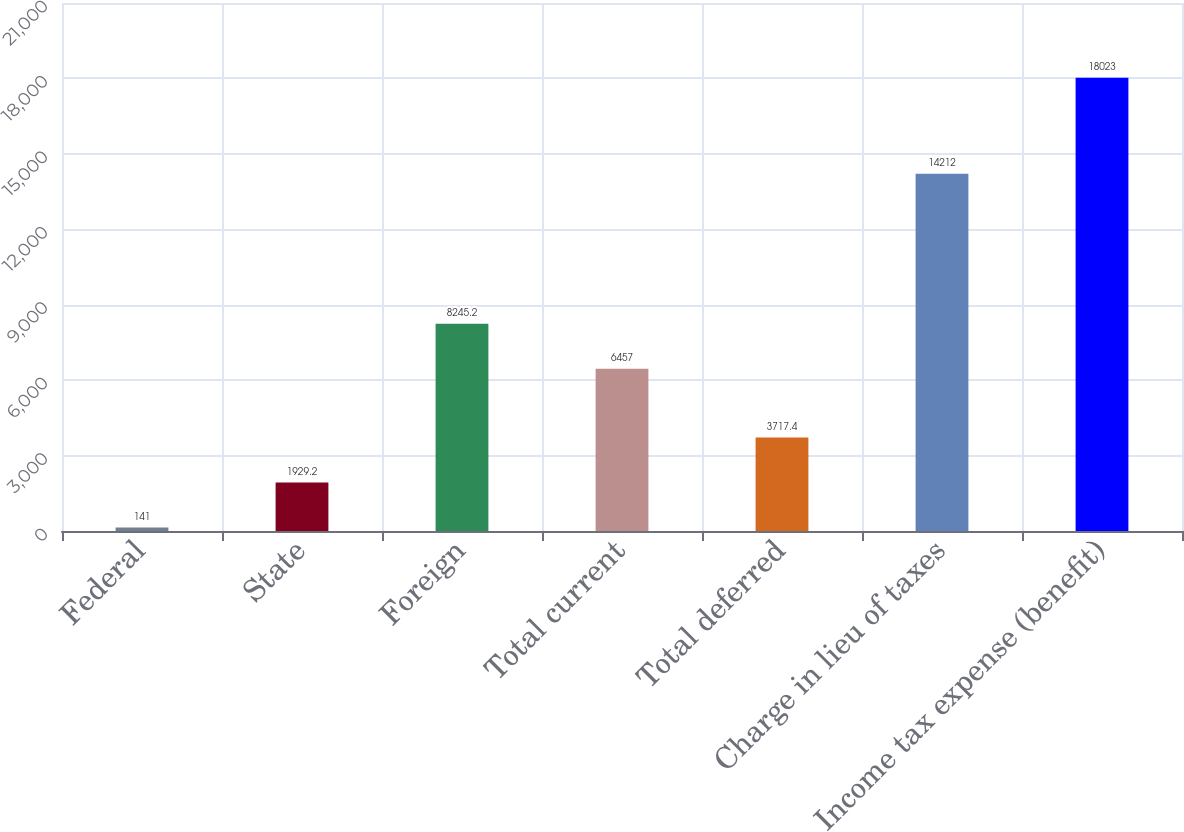<chart> <loc_0><loc_0><loc_500><loc_500><bar_chart><fcel>Federal<fcel>State<fcel>Foreign<fcel>Total current<fcel>Total deferred<fcel>Charge in lieu of taxes<fcel>Income tax expense (benefit)<nl><fcel>141<fcel>1929.2<fcel>8245.2<fcel>6457<fcel>3717.4<fcel>14212<fcel>18023<nl></chart> 